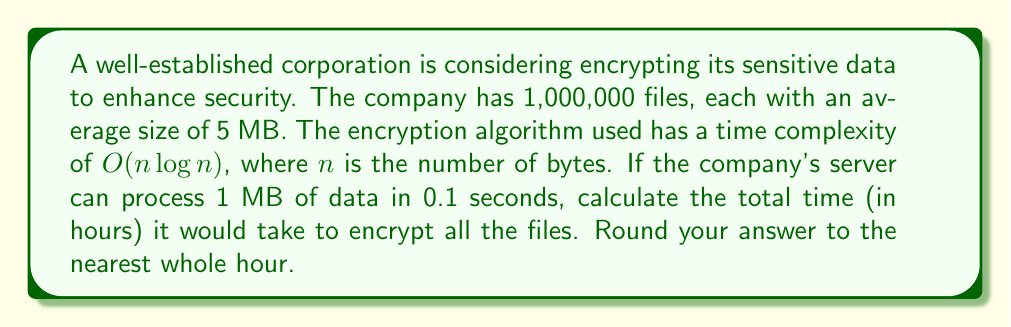Give your solution to this math problem. Let's approach this problem step-by-step:

1) First, we need to calculate the total amount of data to be encrypted:
   $1,000,000 \text{ files} \times 5 \text{ MB/file} = 5,000,000 \text{ MB} = 5 \times 10^6 \text{ MB}$

2) Convert MB to bytes:
   $5 \times 10^6 \text{ MB} \times 10^6 \text{ bytes/MB} = 5 \times 10^{12} \text{ bytes}$

3) The time complexity is $O(n \log n)$, where $n$ is the number of bytes. So, we need to calculate:
   $5 \times 10^{12} \log(5 \times 10^{12})$

4) $\log(5 \times 10^{12}) \approx 42.53$ (using base-2 logarithm)

5) So, the computational cost is proportional to:
   $5 \times 10^{12} \times 42.53 \approx 2.1265 \times 10^{14}$

6) Now, we need to convert this to actual time. We know that the server can process 1 MB in 0.1 seconds.
   $1 \text{ MB} = 10^6 \text{ bytes}$
   $10^6 \text{ bytes} \rightarrow 0.1 \text{ seconds}$

7) So, the time taken for $2.1265 \times 10^{14}$ operations is:
   $\frac{2.1265 \times 10^{14}}{10^6} \times 0.1 = 2.1265 \times 10^7 \text{ seconds}$

8) Convert seconds to hours:
   $\frac{2.1265 \times 10^7}{3600} \approx 5907.08 \text{ hours}$

9) Rounding to the nearest hour:
   $5907 \text{ hours}$
Answer: $5907 \text{ hours}$ 